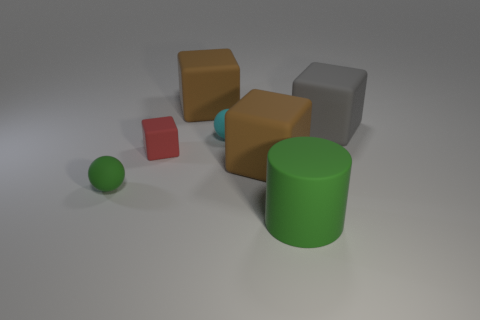Subtract all blue cylinders. How many brown blocks are left? 2 Add 2 small cyan spheres. How many objects exist? 9 Subtract all big blocks. How many blocks are left? 1 Subtract all red blocks. How many blocks are left? 3 Subtract 1 cubes. How many cubes are left? 3 Subtract all green cubes. Subtract all purple cylinders. How many cubes are left? 4 Subtract all cylinders. How many objects are left? 6 Subtract all large gray things. Subtract all tiny cyan balls. How many objects are left? 5 Add 7 green cylinders. How many green cylinders are left? 8 Add 3 red rubber cubes. How many red rubber cubes exist? 4 